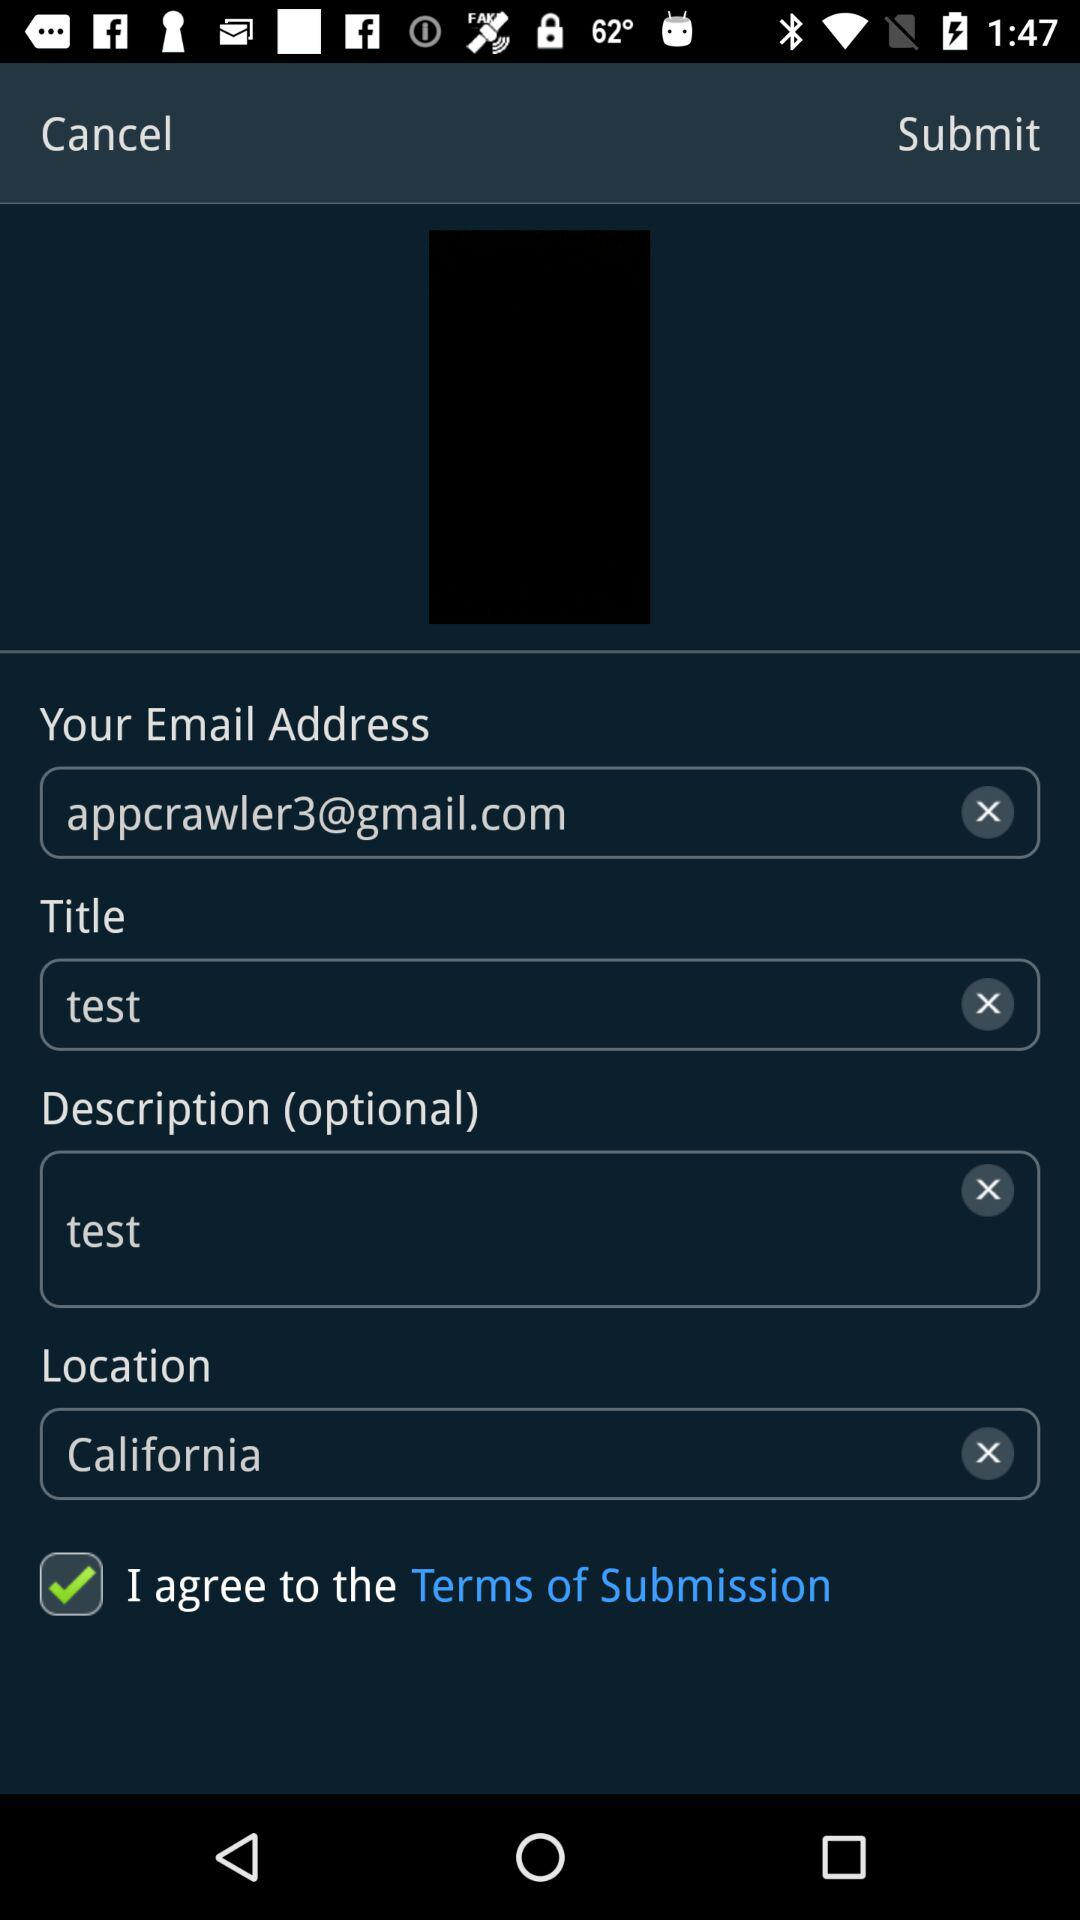How many text inputs are there for the user to fill out?
Answer the question using a single word or phrase. 4 